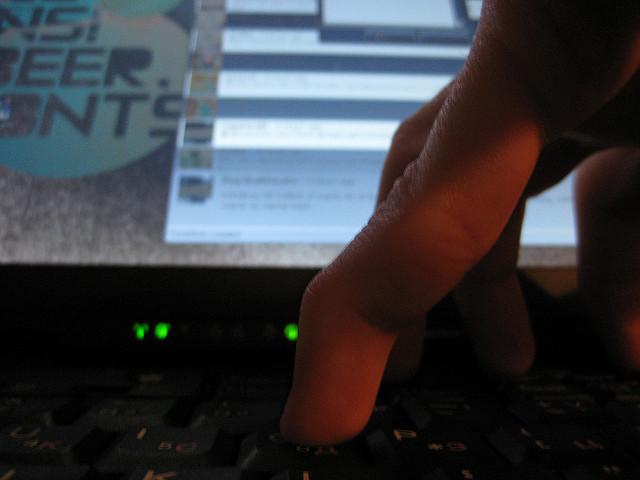Are the fingers normal?
Short answer required. No. What color are the lights on the computer?
Short answer required. Green. Is this person's computer on?
Concise answer only. Yes. What is this person doing?
Short answer required. Typing. 